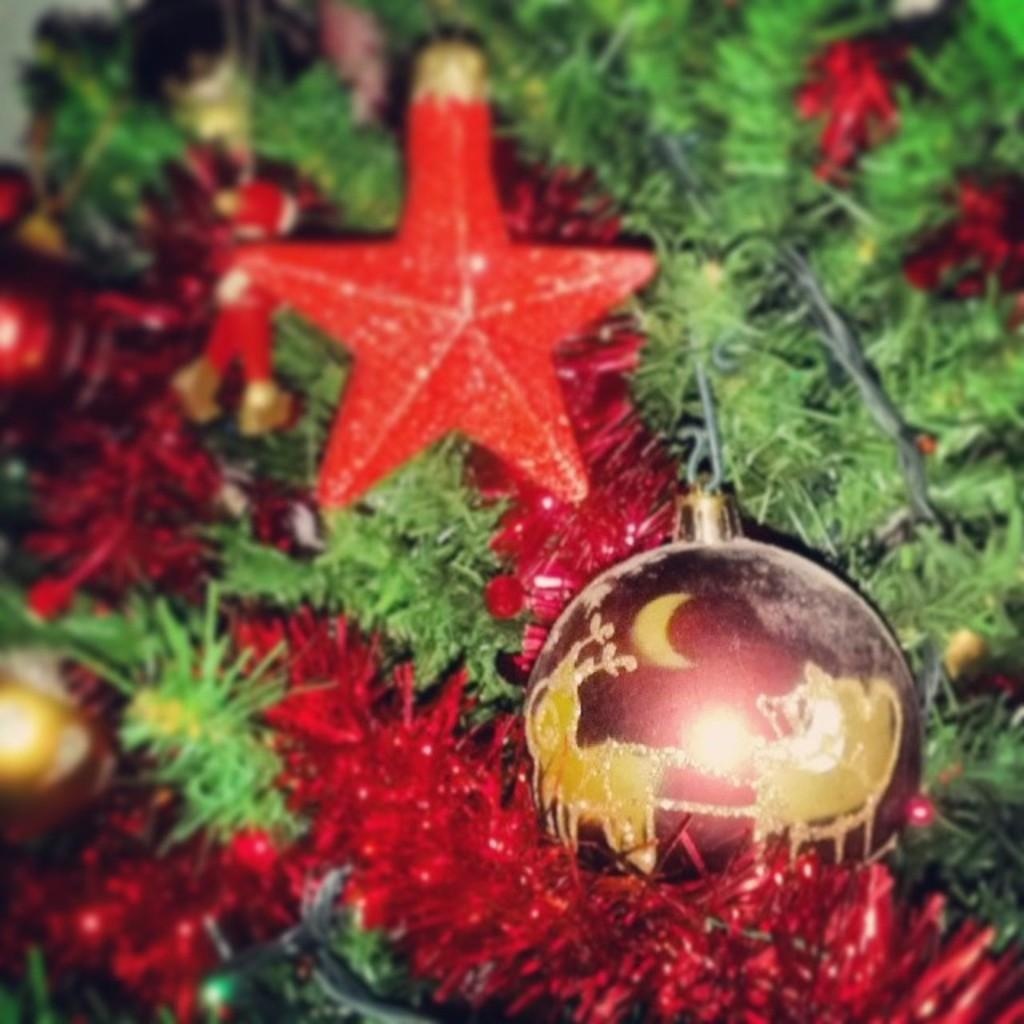What type of tree is in the image? There is a Christmas tree in the image. What can be seen on the Christmas tree? The Christmas tree has decorative items on it, including a ball and a star. What type of bird is perched on the gate in the image? There is no bird or gate present in the image; it only features a Christmas tree with decorative items. 